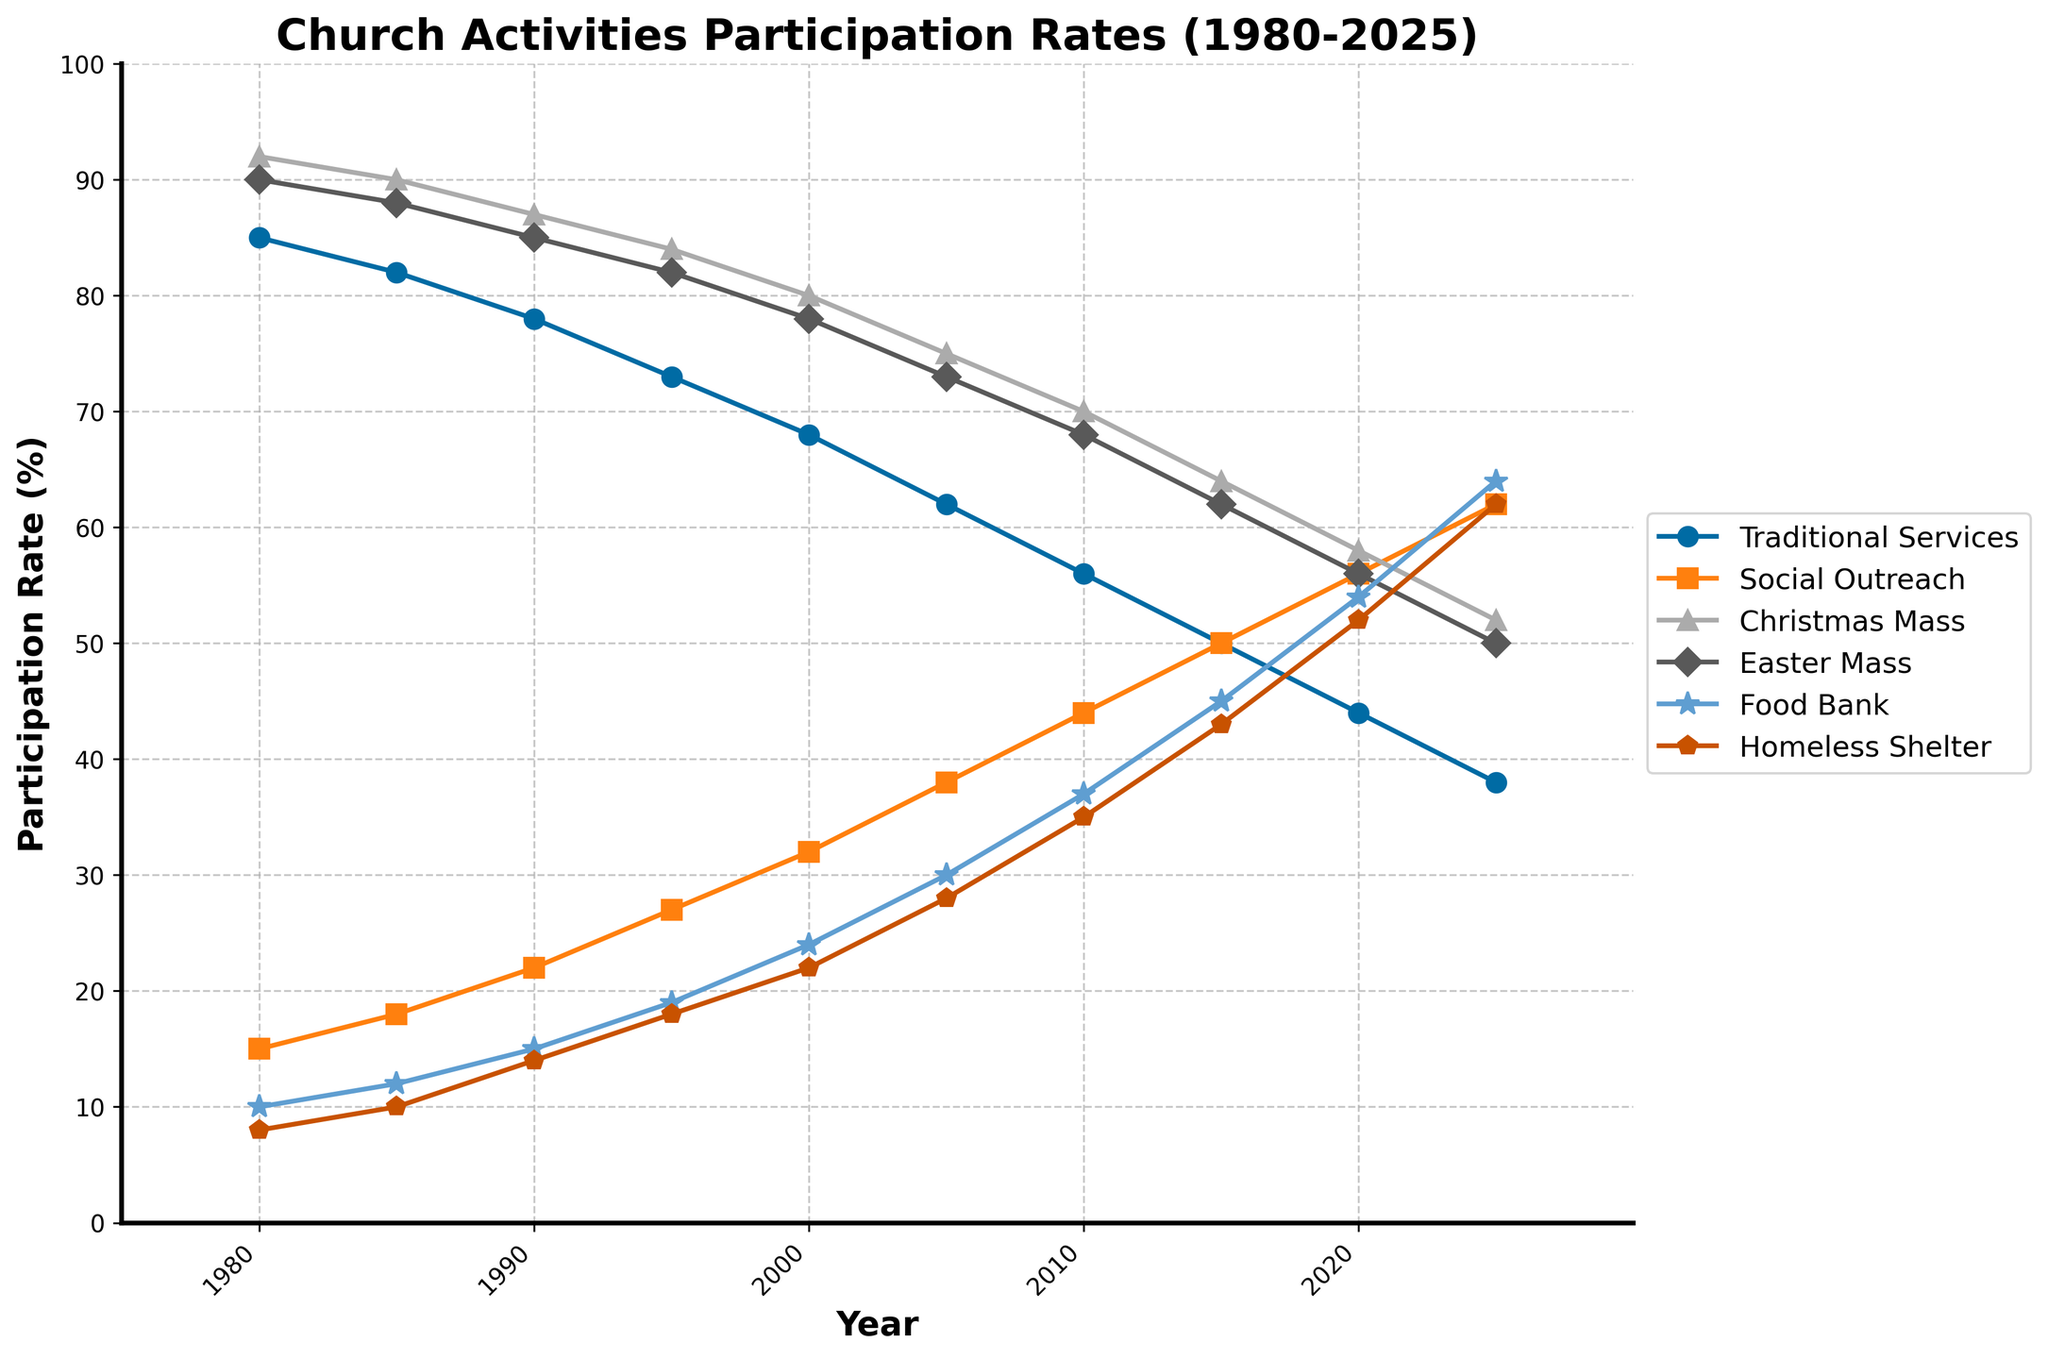Which year had the highest participation rate in social outreach programs? By looking at the figures for "Social Outreach Participation", we see that the highest value is 62%, which occurs in 2025.
Answer: 2025 How much did traditional services attendance decrease from 1980 to 2025? Subtract the 2025 value (38) from the 1980 value (85): 85 - 38.
Answer: 47 Which type of participation saw the most growth from 1980 to 2025? Evaluate the increases: Social Outreach Participation went from 15 to 62 (47 increase), Food Bank Volunteers from 10 to 64 (54 increase), and Homeless Shelter Volunteers from 8 to 62 (54 increase).
Answer: Food Bank Volunteers and Homeless Shelter Volunteers In which year did social outreach participation surpass traditional services attendance? Find the year where social outreach participation first surpasses traditional services attendance, which is 2015 (50% vs 50%).
Answer: 2015 What was the participation rate in food bank volunteering and Christmas mass attendance in 2000? Locate the 2000 values for Food Bank Volunteers and Christmas Mass Attendance: 24 and 80, respectively.
Answer: 24%, 80% Which year saw the largest drop in traditional services attendance? Determine the year-to-year decrease for traditional services attendance and identify the largest drop. The largest drop occurs from 2005 to 2010 (62 to 56, a decline of 6 points).
Answer: 2005-2010 Did participation in outreach programs ever equal that in Easter masses? If so, when? Compare values for outreach programs and Easter Masses across the years. In 2015, both are equal at 50%.
Answer: 2015 How did the participation split between homeless shelter volunteers and food bank volunteers in 2010? Check the values for 2010: Homeless Shelter Volunteers (35) and Food Bank Volunteers (37).
Answer: 35 vs 37 What was the combined participation rate for traditional services attendance and social outreach participation in 1995? Sum the participation rates for traditional services (73) and social outreach (27) in 1995: 73 + 27.
Answer: 100 Which year had the smallest attendance difference between Christmas and Easter masses? Calculate the absolute difference between Christmas and Easter masses for each year and identify the smallest. In 1990, the difference is 2 (87-85).
Answer: 1990 